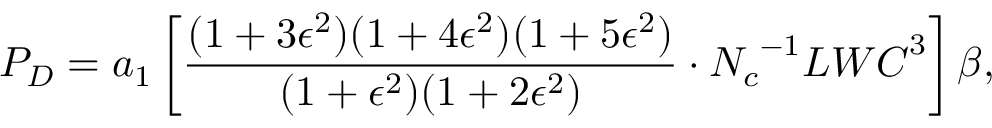<formula> <loc_0><loc_0><loc_500><loc_500>P _ { D } = a _ { 1 } \left [ \frac { ( 1 + 3 \epsilon ^ { 2 } ) ( 1 + 4 \epsilon ^ { 2 } ) ( 1 + 5 \epsilon ^ { 2 } ) } { ( 1 + \epsilon ^ { 2 } ) ( 1 + 2 \epsilon ^ { 2 } ) } \cdot { N _ { c } } ^ { - 1 } { L W C } ^ { 3 } \right ] \beta ,</formula> 